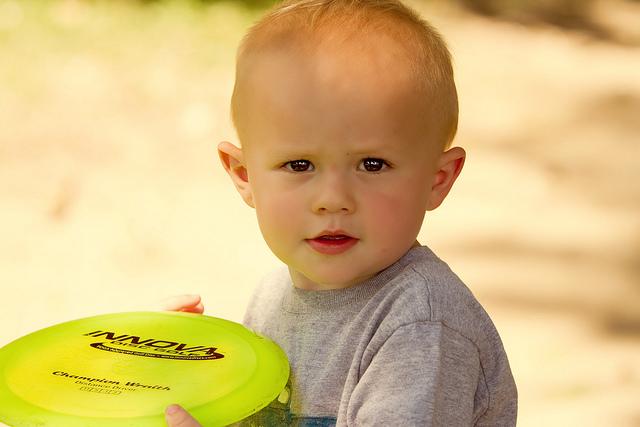What is the baby holding?
Answer briefly. Frisbee. What gender is the baby?
Answer briefly. Boy. What color is the babies eyes?
Write a very short answer. Brown. 